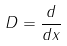Convert formula to latex. <formula><loc_0><loc_0><loc_500><loc_500>D = \frac { d } { d x }</formula> 